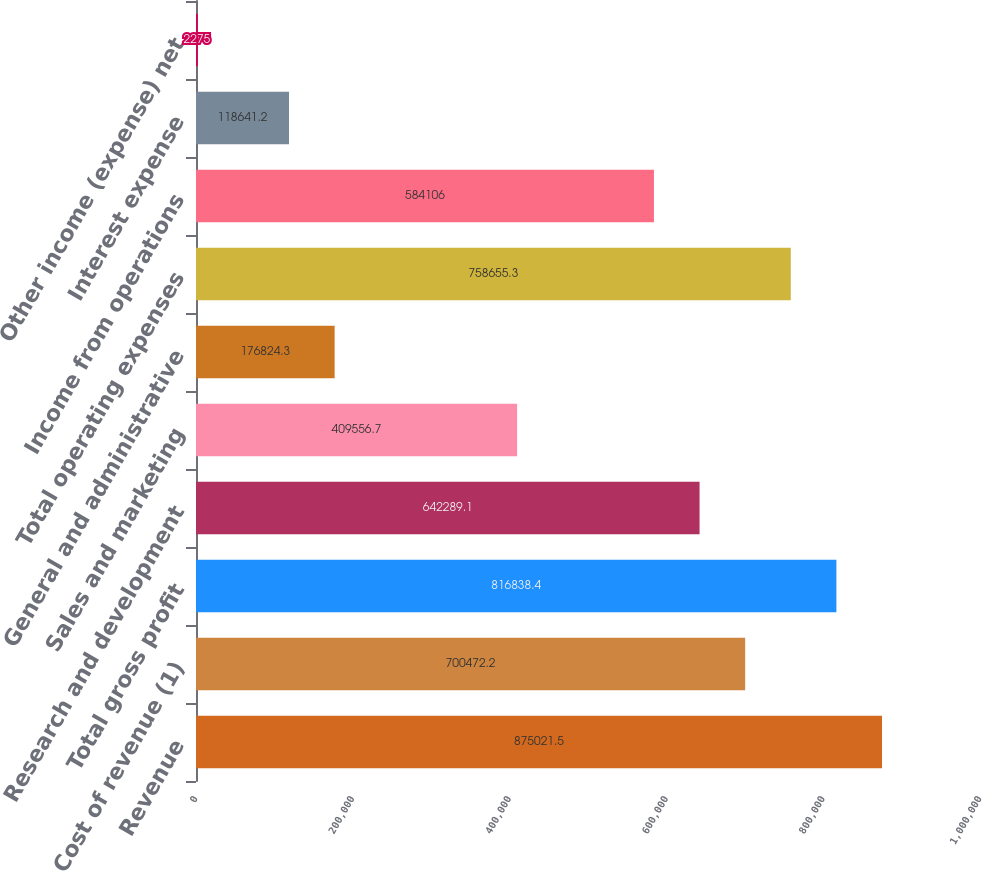Convert chart. <chart><loc_0><loc_0><loc_500><loc_500><bar_chart><fcel>Revenue<fcel>Cost of revenue (1)<fcel>Total gross profit<fcel>Research and development<fcel>Sales and marketing<fcel>General and administrative<fcel>Total operating expenses<fcel>Income from operations<fcel>Interest expense<fcel>Other income (expense) net<nl><fcel>875022<fcel>700472<fcel>816838<fcel>642289<fcel>409557<fcel>176824<fcel>758655<fcel>584106<fcel>118641<fcel>2275<nl></chart> 